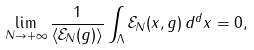Convert formula to latex. <formula><loc_0><loc_0><loc_500><loc_500>\lim _ { N \rightarrow + \infty } \frac { 1 } { \langle \mathcal { E } _ { N } ( g ) \rangle } \int _ { \Lambda } \mathcal { E } _ { N } ( x , g ) \, d ^ { d } x = 0 ,</formula> 